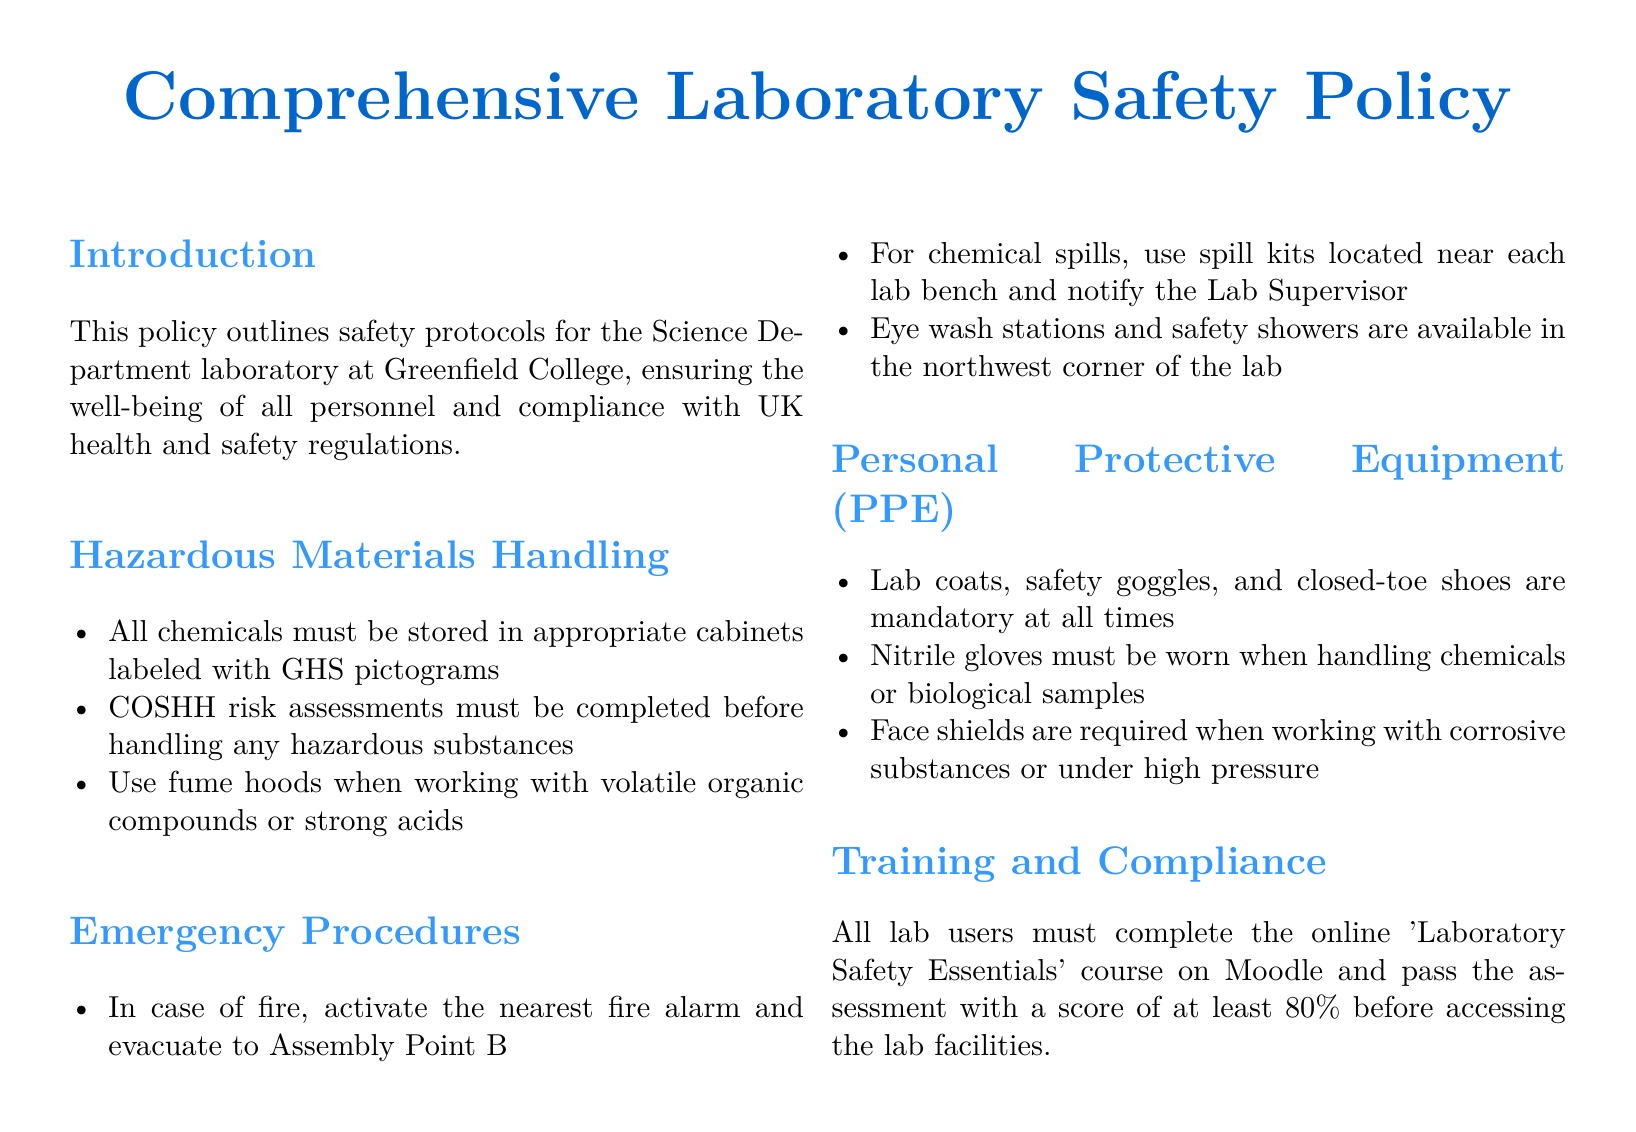What is the title of the document? The title of the document is indicated at the top and is focused on lab safety.
Answer: Comprehensive Laboratory Safety Policy What must be completed before handling hazardous substances? This is specified in the section on hazardous materials handling, which highlights the necessity of risk assessments.
Answer: COSHH risk assessments What is the mandatory footwear in the lab? The section about personal protective equipment outlines the requirement for safety regarding footwear.
Answer: Closed-toe shoes Where should you evacuate in case of a fire? Emergency procedures specify the evacuation point clearly for fire emergencies.
Answer: Assembly Point B What PPE is required when handling chemicals? The personal protective equipment section mentions the specific equipment needed for chemical handling.
Answer: Nitrile gloves How should volatile organic compounds be handled? This question involves understanding appropriate safety measures highlighted in the hazardous materials section.
Answer: Use fume hoods What is the pass score for the 'Laboratory Safety Essentials' course? Training and compliance requirements state the minimum assessment score needed to access lab facilities.
Answer: 80% What equipment is to be used in the event of a chemical spill? The emergency procedures section lists resources available in the lab for spill incidents.
Answer: Spill kits When was this policy document created? The document does not explicitly state a creation date, focusing on current safety protocols instead.
Answer: Not specified 